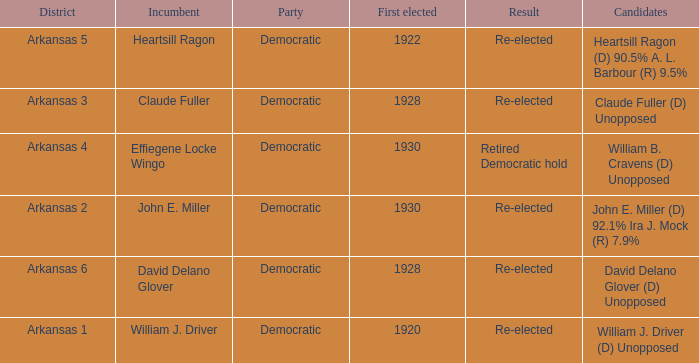What year was incumbent Claude Fuller first elected?  1928.0. 